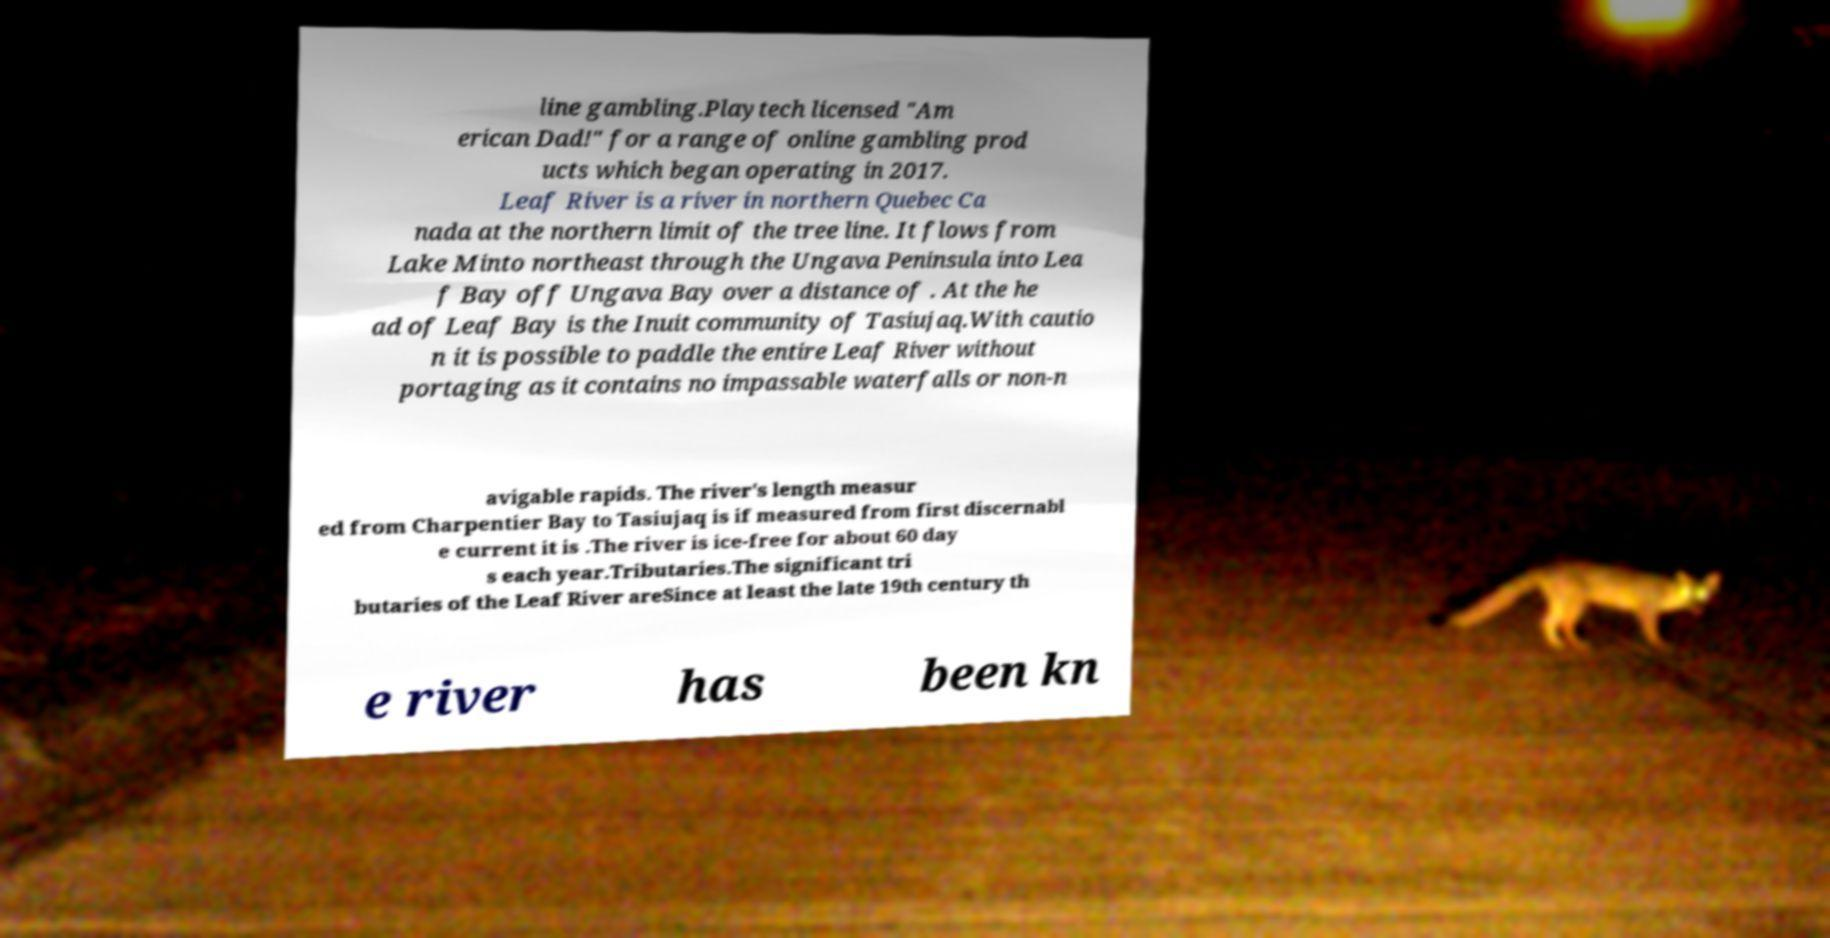Can you read and provide the text displayed in the image?This photo seems to have some interesting text. Can you extract and type it out for me? line gambling.Playtech licensed "Am erican Dad!" for a range of online gambling prod ucts which began operating in 2017. Leaf River is a river in northern Quebec Ca nada at the northern limit of the tree line. It flows from Lake Minto northeast through the Ungava Peninsula into Lea f Bay off Ungava Bay over a distance of . At the he ad of Leaf Bay is the Inuit community of Tasiujaq.With cautio n it is possible to paddle the entire Leaf River without portaging as it contains no impassable waterfalls or non-n avigable rapids. The river's length measur ed from Charpentier Bay to Tasiujaq is if measured from first discernabl e current it is .The river is ice-free for about 60 day s each year.Tributaries.The significant tri butaries of the Leaf River areSince at least the late 19th century th e river has been kn 